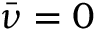Convert formula to latex. <formula><loc_0><loc_0><loc_500><loc_500>\bar { \nu } = 0</formula> 